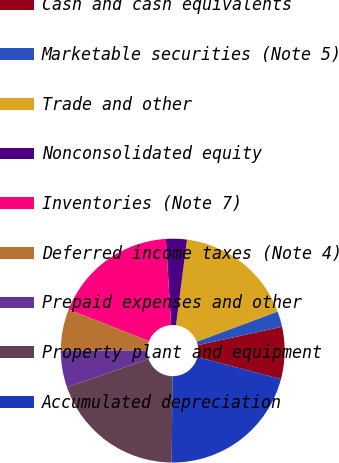<chart> <loc_0><loc_0><loc_500><loc_500><pie_chart><fcel>Cash and cash equivalents<fcel>Marketable securities (Note 5)<fcel>Trade and other<fcel>Nonconsolidated equity<fcel>Inventories (Note 7)<fcel>Deferred income taxes (Note 4)<fcel>Prepaid expenses and other<fcel>Property plant and equipment<fcel>Accumulated depreciation<nl><fcel>7.52%<fcel>2.26%<fcel>17.29%<fcel>3.01%<fcel>18.04%<fcel>6.02%<fcel>5.27%<fcel>19.55%<fcel>21.05%<nl></chart> 